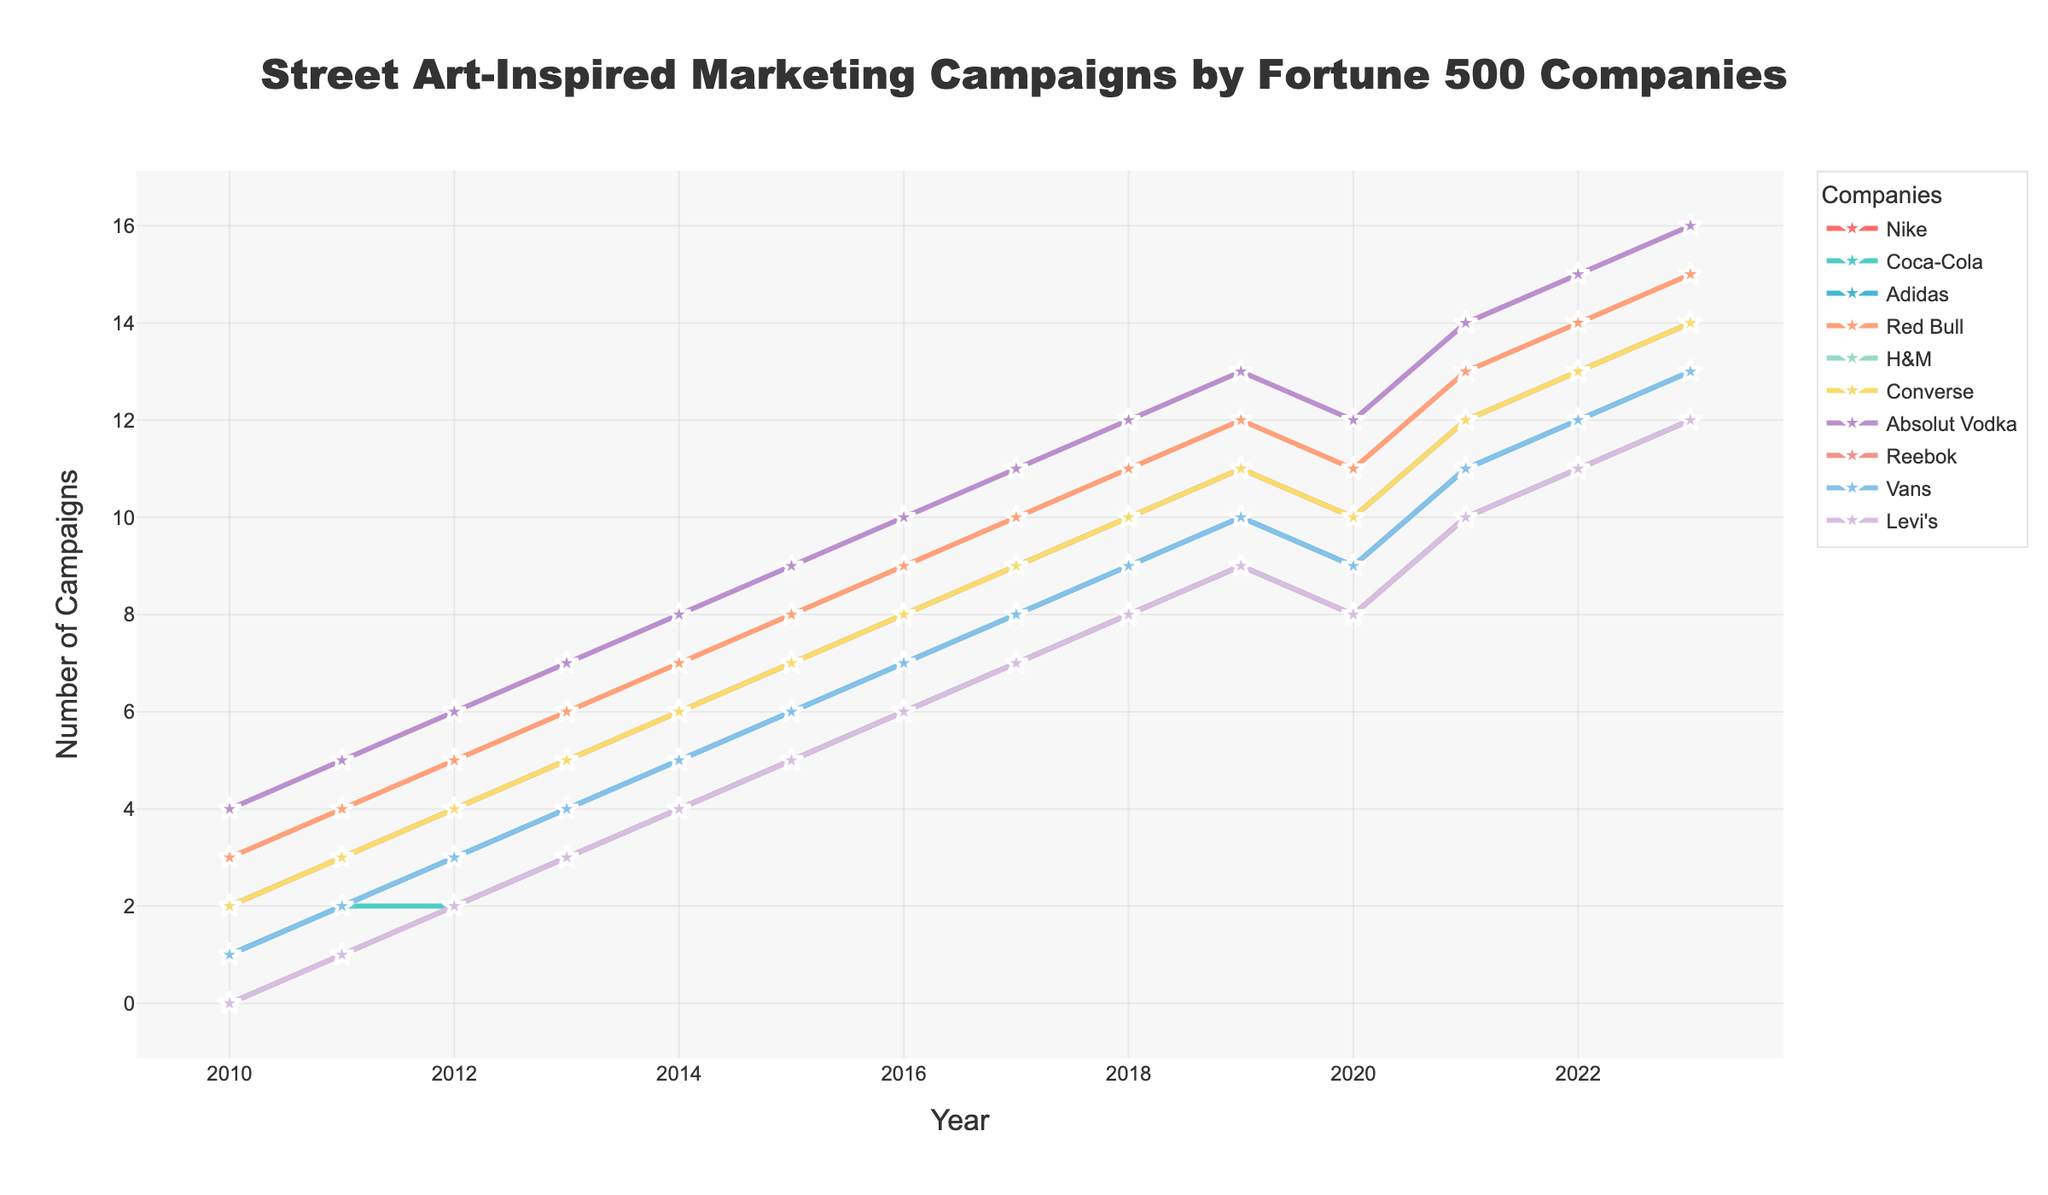What company had the highest number of street art-inspired marketing campaigns in 2016? To find the answer, look at the data points for 2016 and compare them. The company with the highest value in 2016 is Absolut Vodka with 10 campaigns.
Answer: Absolut Vodka How did the number of campaigns for Nike change from 2010 to 2020? To determine this, look at Nike's data points for 2010 and 2020. In 2010, Nike had 2 campaigns, and in 2020, it had 10 campaigns. Calculate the difference: 10 - 2 = 8. Therefore, the number of campaigns increased by 8.
Answer: Increased by 8 Which two companies had the most similar number of campaigns in 2021? Compare the data points for all companies in 2021. Nike and Converse both had 12 campaigns in 2021, indicating they had the most similar numbers.
Answer: Nike and Converse What's the average number of campaigns for Red Bull between 2011 to 2014 inclusive? Look at the values for Red Bull from 2011 to 2014: 4, 5, 6, and 7. Sum up these values: 4 + 5 + 6 + 7 = 22. Next, divide by the number of years (4): 22 / 4 = 5.5.
Answer: 5.5 Did any company experience a decrease in the number of campaigns from 2019 to 2020? Compare the data for each company between 2019 and 2020. Both Nike and Coca-Cola show a decrease: Nike went from 11 to 10, and Coca-Cola from 9 to 8.
Answer: Yes, Nike and Coca-Cola Which company consistently increased its number of campaigns each year from 2010 to 2023 without any decrease? Go through each company's data and check for any dips or fluctuations. Absolut Vodka shows a consistent increase each year from 4 to 16.
Answer: Absolut Vodka By how much did the combined total number of campaigns for all companies increase from 2010 to 2023? Sum the total number of campaigns for all companies in 2010: 2 + 1 + 1 + 3 + 0 + 2 + 4 + 0 + 1 + 0 = 14. Then do the same for 2023: 14 + 12 + 13 + 15 + 12 + 14 + 16 + 12 + 13 + 12 = 133. The increase is 133 - 14 = 119.
Answer: Increased by 119 Which company had the steepest increase in the number of campaigns from 2011 to 2013? Calculate the difference for each company between 2011 and 2013. The company with the highest increase over these years is Adidas, which increased from 2 campaigns in 2011 to 4 in 2013, a difference of 2.
Answer: Adidas 